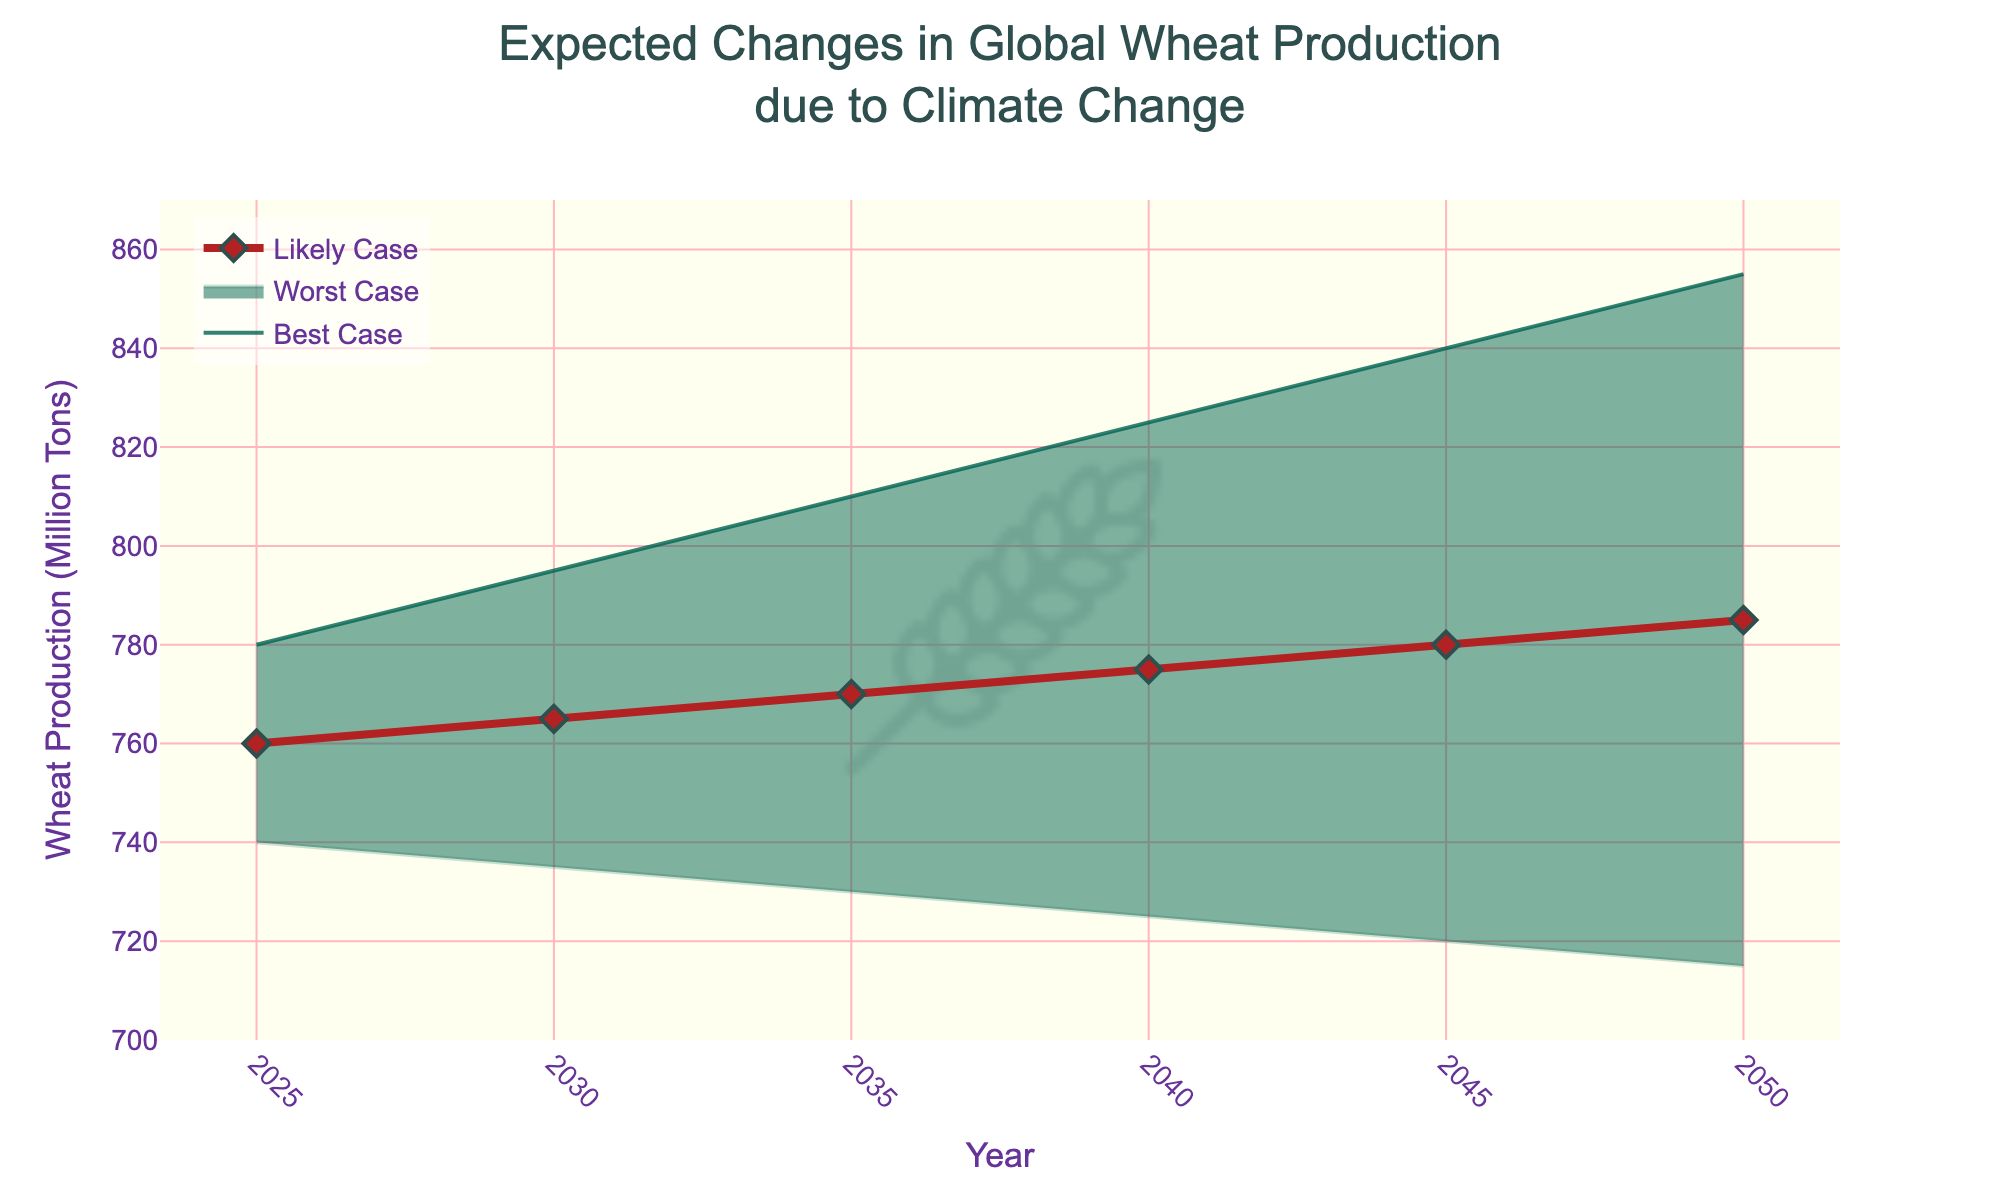What does the title of the chart indicate? The title of the chart is "Expected Changes in Global Wheat Production due to Climate Change," indicating the chart is presenting predicted variations in global wheat production under different climate change scenarios.
Answer: Expected changes in global wheat production due to climate change Which year shows the highest wheat production in the best-case scenario? The best-case scenario line reaches its highest point in the year 2050, where the wheat production is 855 million tons.
Answer: 2050 What is the wheat production in the worst-case scenario for the year 2040? For the year 2040, the worst-case scenario line indicates a production level of 725 million tons.
Answer: 725 million tons How does the likely case scenario change from 2025 to 2045? In 2025, the likely case scenario shows a production of 760 million tons, and in 2045 it shows 780 million tons.
Answer: It increases by 20 million tons What is the difference in wheat production between the best-case and worst-case scenarios in 2035? In 2035, the best-case scenario is 810 million tons, and the worst-case scenario is 730 million tons. The difference is 810 - 730 = 80 million tons.
Answer: 80 million tons Which year shows the smallest gap between the best-case and worst-case scenarios? To find this, observe the difference between the best and worst-case scenarios in each year: 40 (2025), 60 (2030), 80 (2035), 100 (2040), 120 (2045), 140 (2050). The smallest gap is in 2025, with a 40 million tons difference.
Answer: 2025 How does the likely case scenario in 2040 compare to the best-case scenario in 2025? In 2040, the likely case is 775 million tons, which is higher than the best-case scenario in 2025 at 780 million tons.
Answer: The 2040 likely case is higher by 15 million tons What are the three scenario predictions for the year 2050? In 2050, the best-case scenario predicts 855 million tons, the likely case predicts 785 million tons, and the worst-case scenario predicts 715 million tons.
Answer: Best: 855, Likely: 785, Worst: 715 What does the color of the lines indicate on the chart? The colors help differentiate the scenarios: a deeper shade of green represents the best-case scenario, a lighter shade of green represents the worst-case scenario, and a red line with diamond markers represents the likely case.
Answer: Best: green, Worst: light green, Likely: red with diamonds 